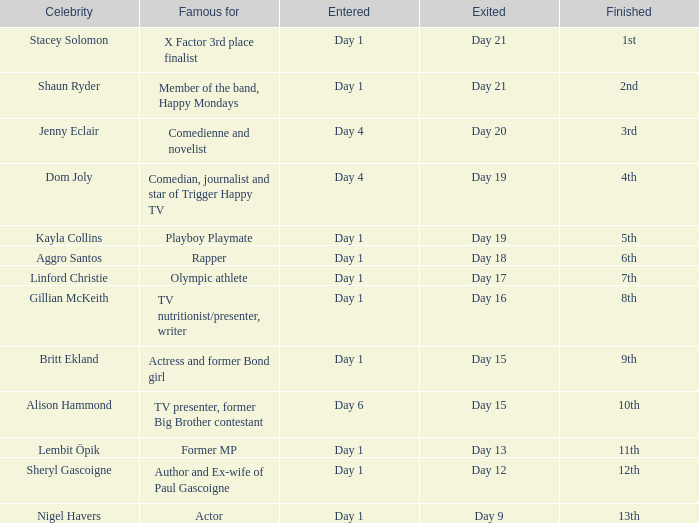Which famous person was known for their rap career? Aggro Santos. 